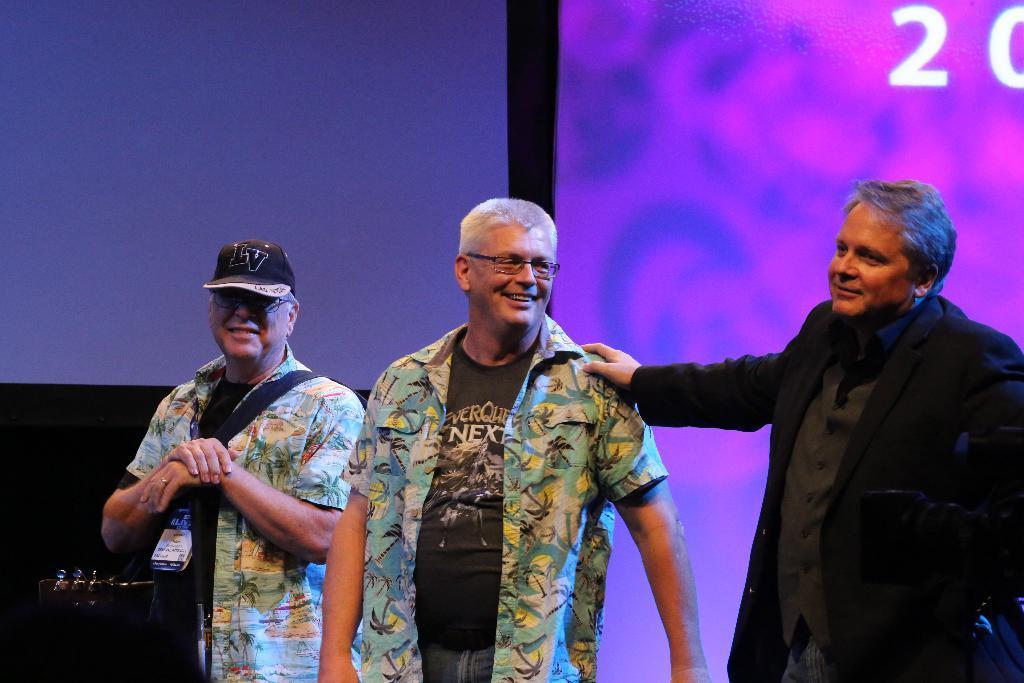Could you give a brief overview of what you see in this image? In this picture we can see there are three people standing and a person is with a cap and a musical instrument. Behind the people, it looks like a screen. 